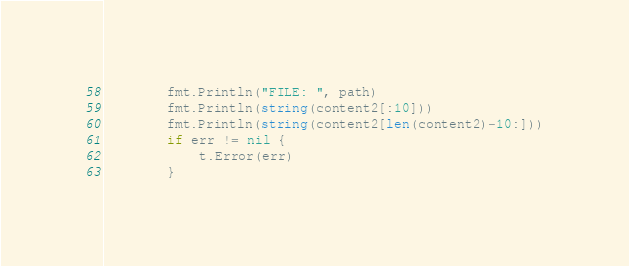<code> <loc_0><loc_0><loc_500><loc_500><_Go_>		fmt.Println("FILE: ", path)
		fmt.Println(string(content2[:10]))
		fmt.Println(string(content2[len(content2)-10:]))
		if err != nil {
			t.Error(err)
		}</code> 